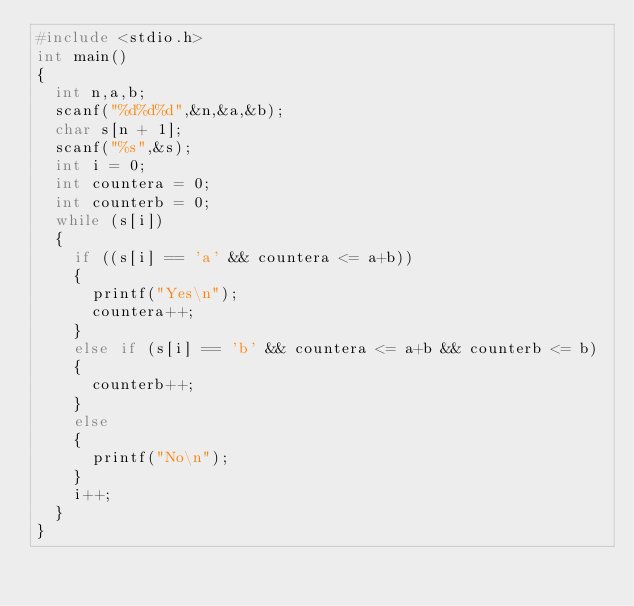<code> <loc_0><loc_0><loc_500><loc_500><_C_>#include <stdio.h>
int main()
{
  int n,a,b;
  scanf("%d%d%d",&n,&a,&b);
  char s[n + 1];
  scanf("%s",&s);
  int i = 0;
  int countera = 0;
  int counterb = 0;
  while (s[i])
  {
    if ((s[i] == 'a' && countera <= a+b))
    {
      printf("Yes\n");
      countera++;
    }
    else if (s[i] == 'b' && countera <= a+b && counterb <= b)
    {
      counterb++;
    }
    else
    {
      printf("No\n");
    }
    i++;
  }
}</code> 